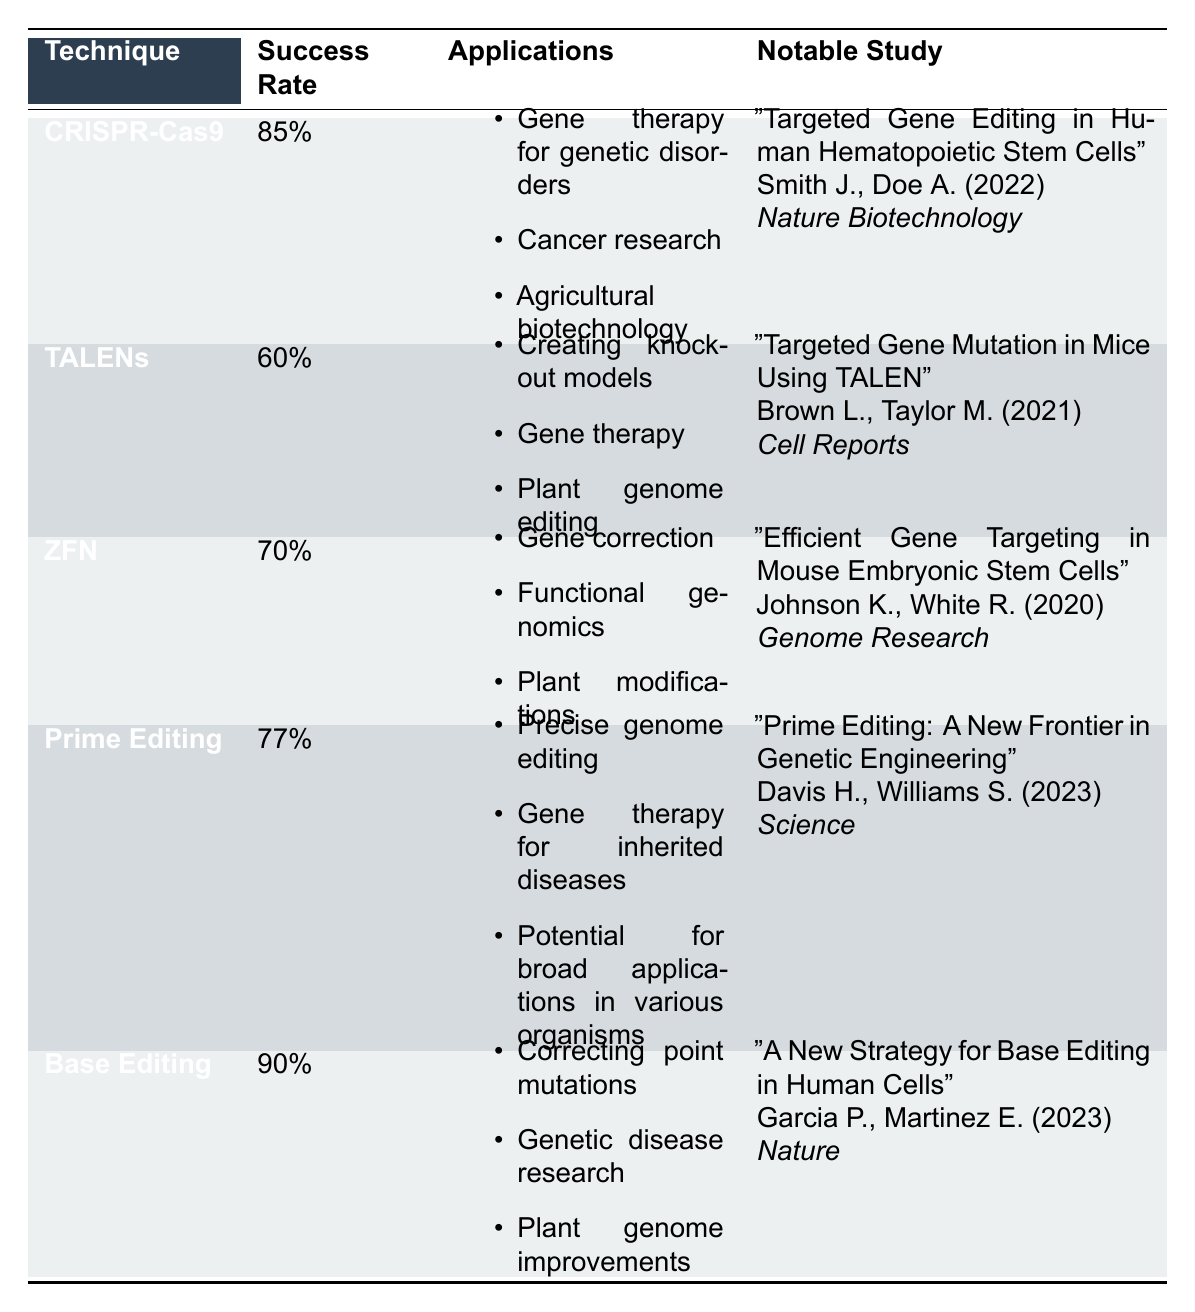What is the success rate of CRISPR-Cas9? According to the table, the success rate of CRISPR-Cas9 is listed directly in the success rate column.
Answer: 85% Which technique has the highest success rate? By comparing the success rates listed for each technique, Base Editing has the highest success rate at 90%.
Answer: Base Editing Is TALENs more successful than ZFN? The table states that TALENs has a success rate of 60% while ZFN has a success rate of 70%. Since 70% is greater than 60%, ZFN is more successful than TALENs.
Answer: No List one application of Prime Editing. The table mentions three applications for Prime Editing, one of which is precise genome editing. This can be directly retrieved from the applications section under Prime Editing.
Answer: Precise genome editing What is the average success rate of the techniques listed? To calculate the average, sum the success rates of all techniques: 85% + 60% + 70% + 77% + 90% = 382%. There are 5 techniques, so the average is 382% / 5 = 76.4%.
Answer: 76.4% Which technique can be used for gene therapy? Both CRISPR-Cas9 and TALENs are mentioned under applications for gene therapy in the table, confirming that these techniques can be used for this purpose.
Answer: Yes What is the notable study associated with Base Editing? The table provides specific details under the notable study column for Base Editing, stating its title, authors, publication year, and journal. The notable study is "A New Strategy for Base Editing in Human Cells" by Garcia P. and Martinez E. in 2023 published in Nature.
Answer: "A New Strategy for Base Editing in Human Cells" by Garcia P., Martinez E. (2023) in Nature How many applications are listed for ZFN? The table lists three applications for ZFN, which can be counted directly from the applications section associated with this technique.
Answer: 3 Which gene editing technique is the most recent study published about? The table indicates that Base Editing and Prime Editing have studies published in 2023. Among these, both techniques are the most recent but Prime Editing is specifically listed first in the notable study column.
Answer: Prime Editing 